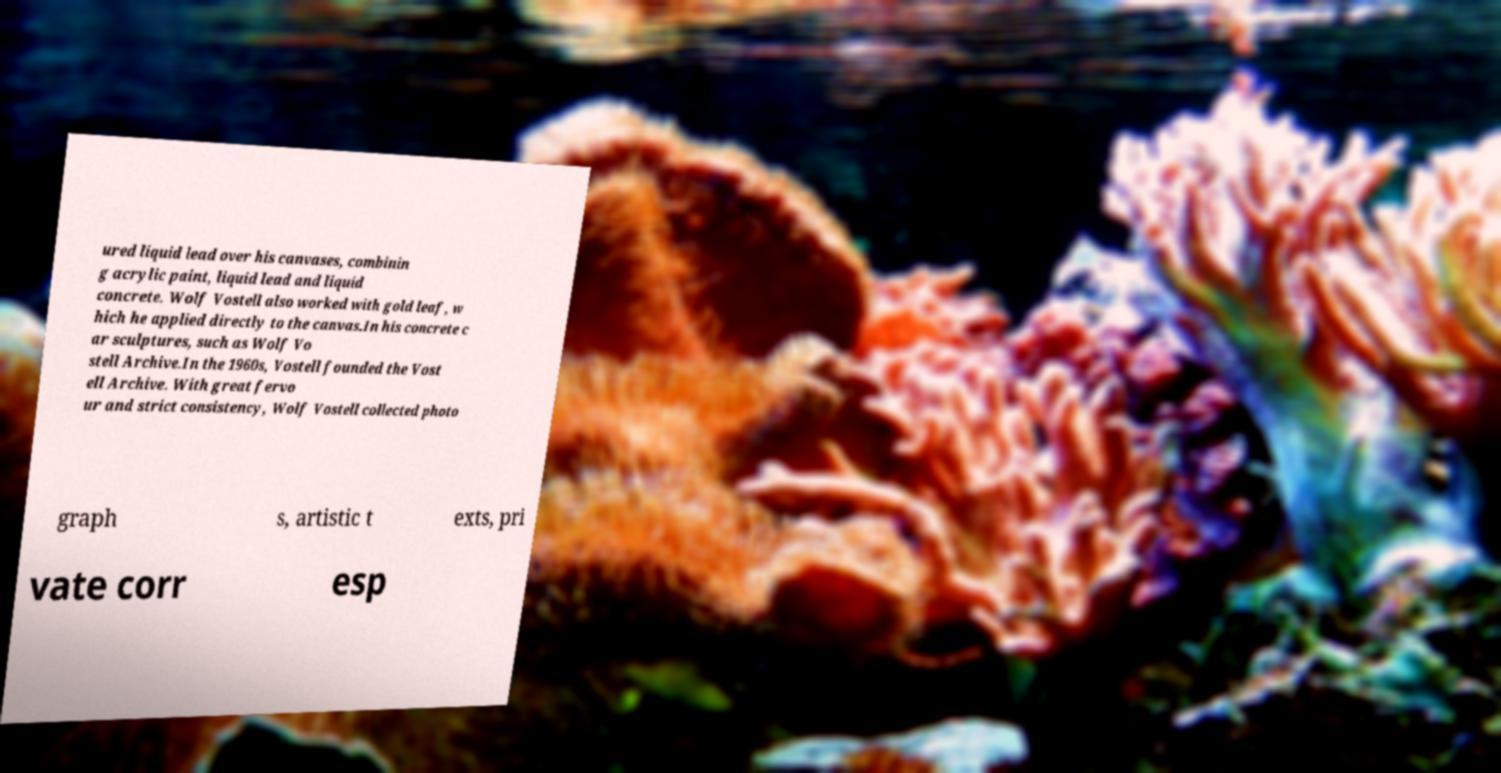I need the written content from this picture converted into text. Can you do that? ured liquid lead over his canvases, combinin g acrylic paint, liquid lead and liquid concrete. Wolf Vostell also worked with gold leaf, w hich he applied directly to the canvas.In his concrete c ar sculptures, such as Wolf Vo stell Archive.In the 1960s, Vostell founded the Vost ell Archive. With great fervo ur and strict consistency, Wolf Vostell collected photo graph s, artistic t exts, pri vate corr esp 